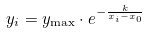Convert formula to latex. <formula><loc_0><loc_0><loc_500><loc_500>y _ { i } = y _ { \max } \cdot e ^ { - \frac { k } { x _ { i } - x _ { 0 } } }</formula> 